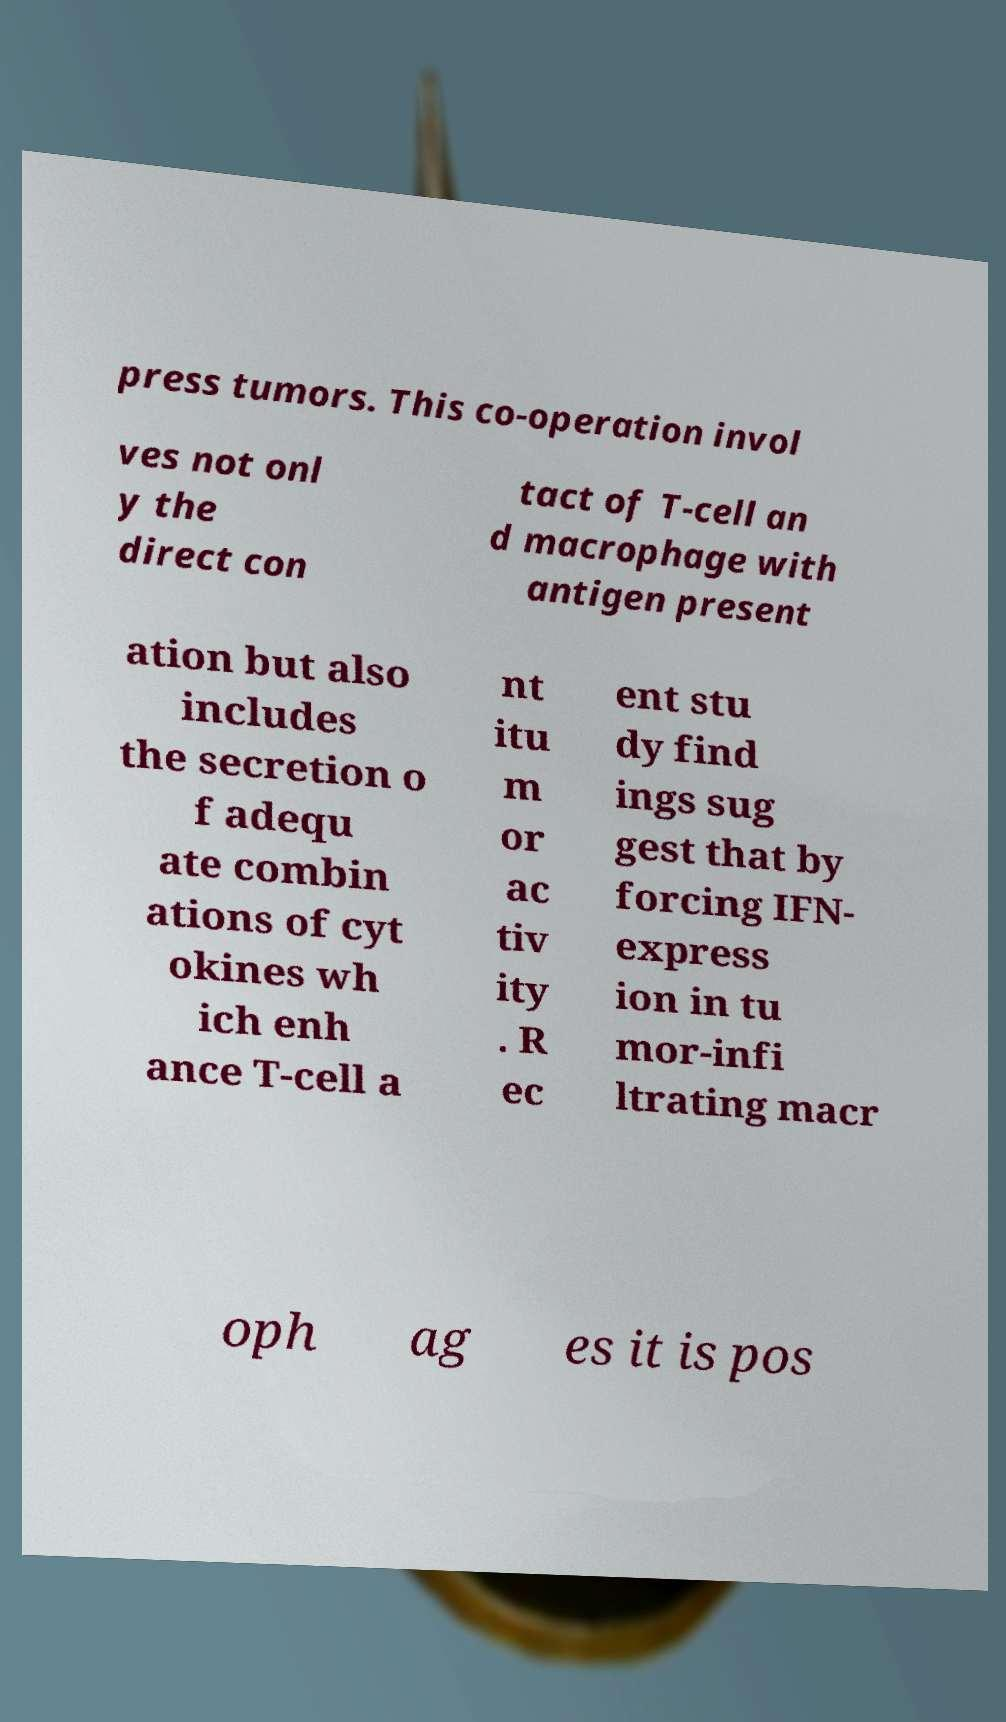For documentation purposes, I need the text within this image transcribed. Could you provide that? press tumors. This co-operation invol ves not onl y the direct con tact of T-cell an d macrophage with antigen present ation but also includes the secretion o f adequ ate combin ations of cyt okines wh ich enh ance T-cell a nt itu m or ac tiv ity . R ec ent stu dy find ings sug gest that by forcing IFN- express ion in tu mor-infi ltrating macr oph ag es it is pos 